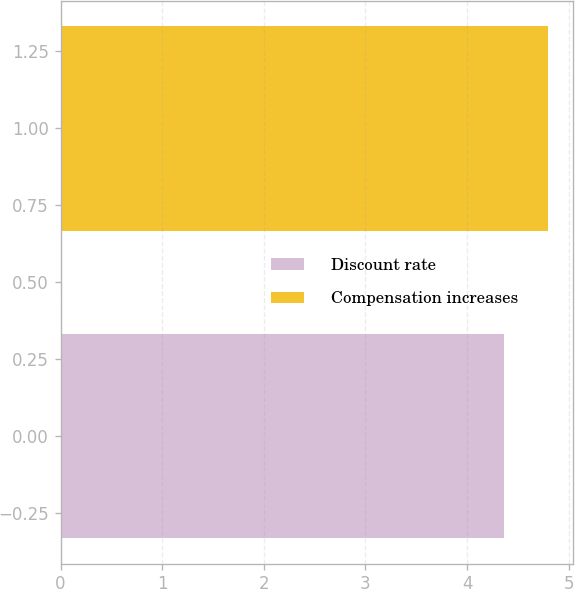<chart> <loc_0><loc_0><loc_500><loc_500><bar_chart><fcel>Discount rate<fcel>Compensation increases<nl><fcel>4.36<fcel>4.8<nl></chart> 